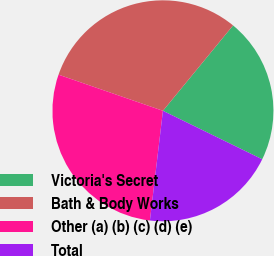Convert chart. <chart><loc_0><loc_0><loc_500><loc_500><pie_chart><fcel>Victoria's Secret<fcel>Bath & Body Works<fcel>Other (a) (b) (c) (d) (e)<fcel>Total<nl><fcel>21.29%<fcel>30.64%<fcel>28.42%<fcel>19.65%<nl></chart> 